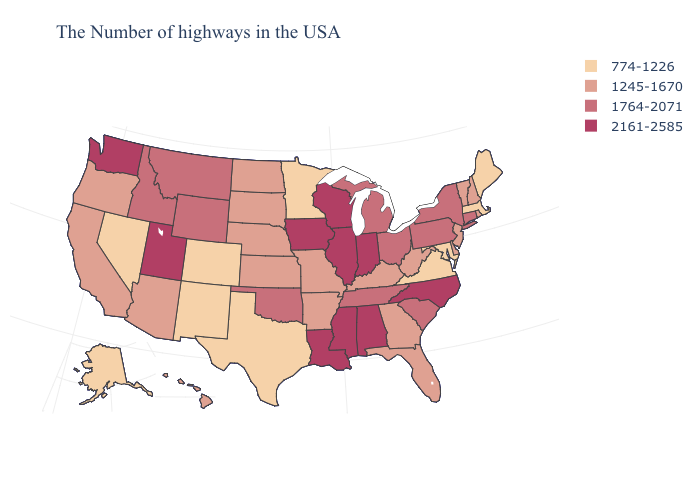Which states have the lowest value in the USA?
Concise answer only. Maine, Massachusetts, Maryland, Virginia, Minnesota, Texas, Colorado, New Mexico, Nevada, Alaska. Which states hav the highest value in the MidWest?
Keep it brief. Indiana, Wisconsin, Illinois, Iowa. Name the states that have a value in the range 2161-2585?
Quick response, please. North Carolina, Indiana, Alabama, Wisconsin, Illinois, Mississippi, Louisiana, Iowa, Utah, Washington. What is the lowest value in the USA?
Short answer required. 774-1226. Name the states that have a value in the range 1245-1670?
Quick response, please. Rhode Island, New Hampshire, Vermont, New Jersey, Delaware, West Virginia, Florida, Georgia, Kentucky, Missouri, Arkansas, Kansas, Nebraska, South Dakota, North Dakota, Arizona, California, Oregon, Hawaii. Does Missouri have the lowest value in the USA?
Short answer required. No. Does Delaware have the highest value in the USA?
Concise answer only. No. What is the highest value in states that border Florida?
Write a very short answer. 2161-2585. What is the value of Maine?
Answer briefly. 774-1226. Is the legend a continuous bar?
Quick response, please. No. What is the value of Mississippi?
Short answer required. 2161-2585. Does the map have missing data?
Be succinct. No. Name the states that have a value in the range 774-1226?
Keep it brief. Maine, Massachusetts, Maryland, Virginia, Minnesota, Texas, Colorado, New Mexico, Nevada, Alaska. What is the value of New Hampshire?
Quick response, please. 1245-1670. Name the states that have a value in the range 774-1226?
Keep it brief. Maine, Massachusetts, Maryland, Virginia, Minnesota, Texas, Colorado, New Mexico, Nevada, Alaska. 